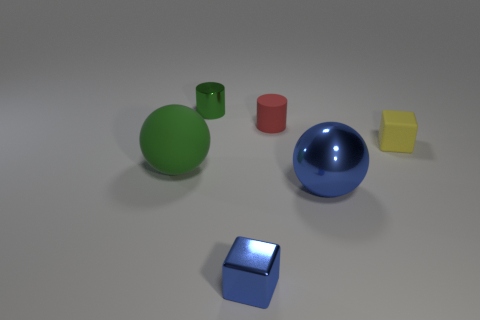There is a ball that is left of the tiny shiny thing that is to the left of the cube that is on the left side of the yellow matte thing; what size is it?
Give a very brief answer. Large. What is the material of the blue cube that is the same size as the red matte cylinder?
Offer a terse response. Metal. Are there any other metal objects of the same size as the red object?
Your answer should be compact. Yes. Does the green matte thing have the same shape as the large metal object?
Offer a very short reply. Yes. There is a ball in front of the ball behind the big blue shiny ball; are there any blue objects that are to the right of it?
Ensure brevity in your answer.  No. How many other things are the same color as the big matte object?
Provide a short and direct response. 1. Do the green thing that is in front of the green cylinder and the cube behind the blue shiny block have the same size?
Ensure brevity in your answer.  No. Are there an equal number of big spheres on the left side of the blue metal cube and tiny metallic cubes right of the tiny red thing?
Give a very brief answer. No. Do the rubber sphere and the ball that is on the right side of the metal cylinder have the same size?
Make the answer very short. Yes. What is the small cube that is in front of the ball that is to the left of the green shiny cylinder made of?
Give a very brief answer. Metal. 